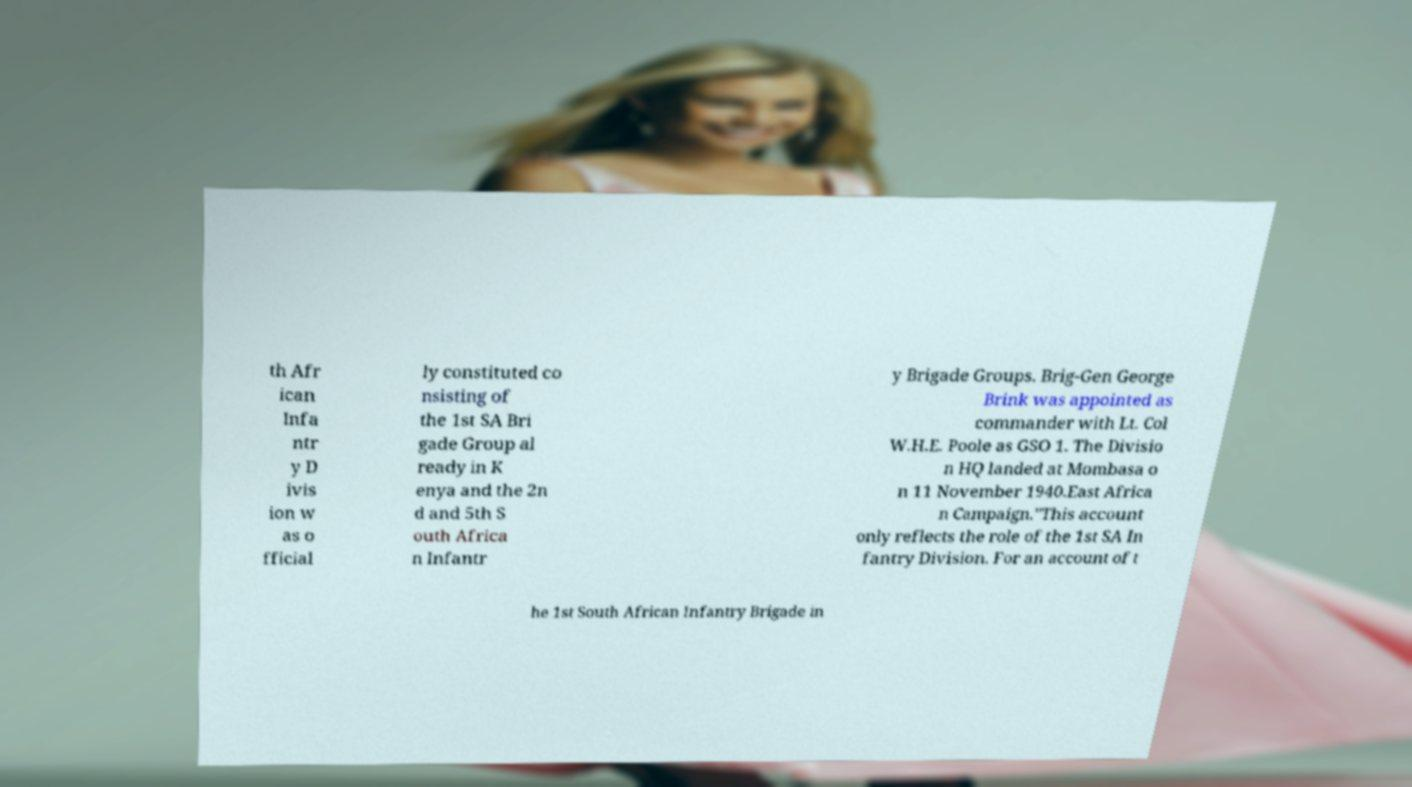Could you assist in decoding the text presented in this image and type it out clearly? th Afr ican Infa ntr y D ivis ion w as o fficial ly constituted co nsisting of the 1st SA Bri gade Group al ready in K enya and the 2n d and 5th S outh Africa n Infantr y Brigade Groups. Brig-Gen George Brink was appointed as commander with Lt. Col W.H.E. Poole as GSO 1. The Divisio n HQ landed at Mombasa o n 11 November 1940.East Africa n Campaign."This account only reflects the role of the 1st SA In fantry Division. For an account of t he 1st South African Infantry Brigade in 